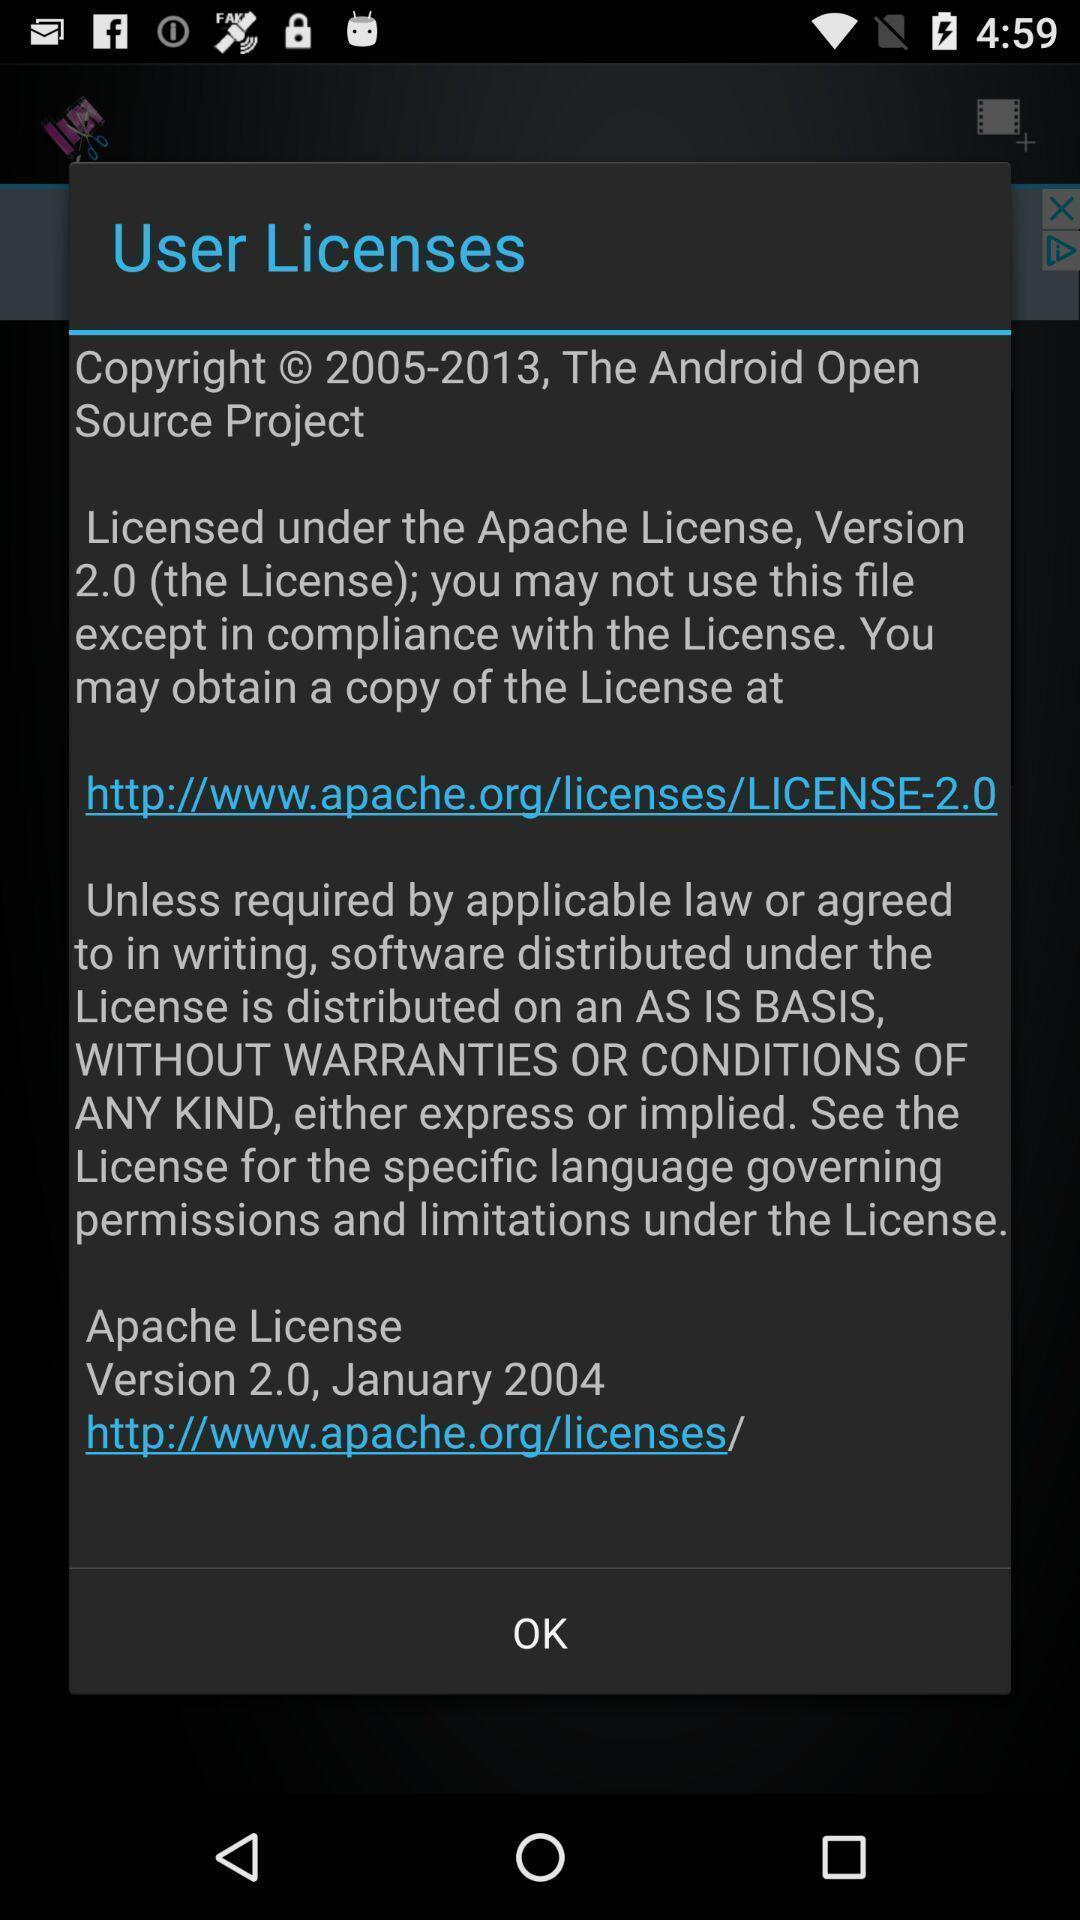What details can you identify in this image? Pop-up giving information about user licenses. 